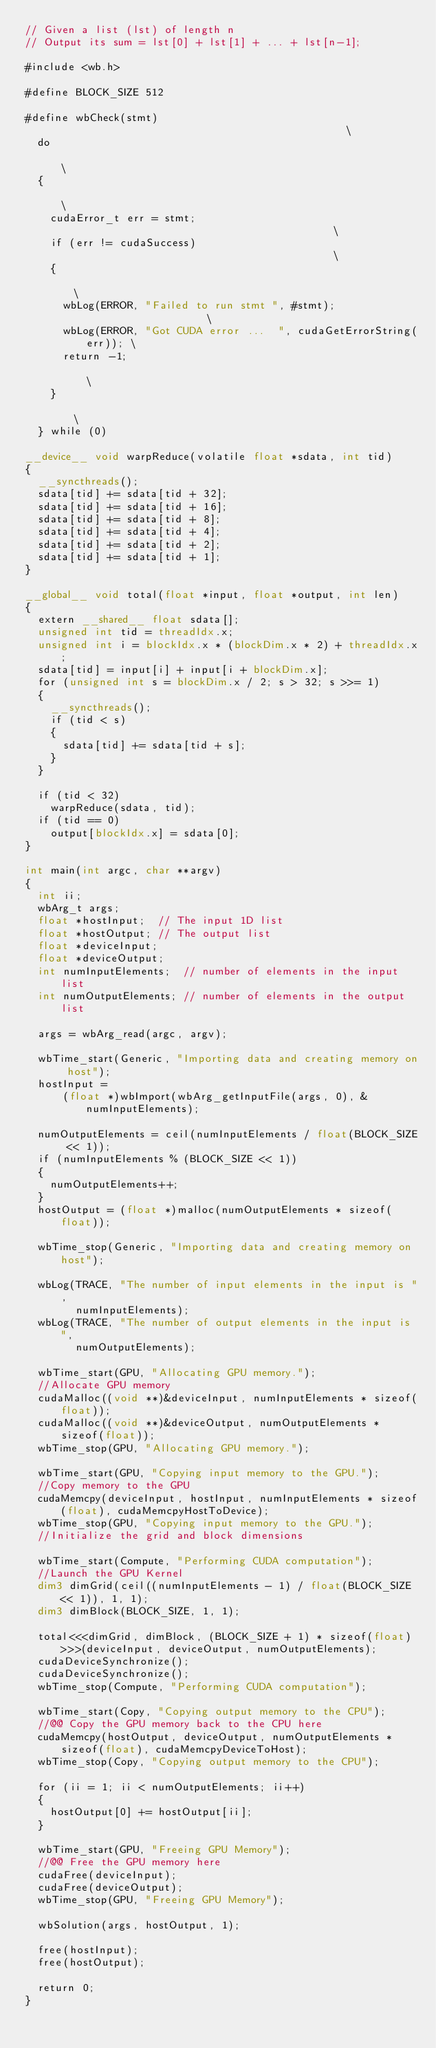Convert code to text. <code><loc_0><loc_0><loc_500><loc_500><_Cuda_>// Given a list (lst) of length n
// Output its sum = lst[0] + lst[1] + ... + lst[n-1];

#include <wb.h>

#define BLOCK_SIZE 512

#define wbCheck(stmt)                                                \
  do                                                                 \
  {                                                                  \
    cudaError_t err = stmt;                                          \
    if (err != cudaSuccess)                                          \
    {                                                                \
      wbLog(ERROR, "Failed to run stmt ", #stmt);                    \
      wbLog(ERROR, "Got CUDA error ...  ", cudaGetErrorString(err)); \
      return -1;                                                     \
    }                                                                \
  } while (0)

__device__ void warpReduce(volatile float *sdata, int tid)
{
  __syncthreads();
  sdata[tid] += sdata[tid + 32];
  sdata[tid] += sdata[tid + 16];
  sdata[tid] += sdata[tid + 8];
  sdata[tid] += sdata[tid + 4];
  sdata[tid] += sdata[tid + 2];
  sdata[tid] += sdata[tid + 1];
}

__global__ void total(float *input, float *output, int len)
{
  extern __shared__ float sdata[];
  unsigned int tid = threadIdx.x;
  unsigned int i = blockIdx.x * (blockDim.x * 2) + threadIdx.x;
  sdata[tid] = input[i] + input[i + blockDim.x];
  for (unsigned int s = blockDim.x / 2; s > 32; s >>= 1)
  {
    __syncthreads();
    if (tid < s)
    {
      sdata[tid] += sdata[tid + s];
    }
  }

  if (tid < 32)
    warpReduce(sdata, tid);
  if (tid == 0)
    output[blockIdx.x] = sdata[0];
}

int main(int argc, char **argv)
{
  int ii;
  wbArg_t args;
  float *hostInput;  // The input 1D list
  float *hostOutput; // The output list
  float *deviceInput;
  float *deviceOutput;
  int numInputElements;  // number of elements in the input list
  int numOutputElements; // number of elements in the output list

  args = wbArg_read(argc, argv);

  wbTime_start(Generic, "Importing data and creating memory on host");
  hostInput =
      (float *)wbImport(wbArg_getInputFile(args, 0), &numInputElements);

  numOutputElements = ceil(numInputElements / float(BLOCK_SIZE << 1));
  if (numInputElements % (BLOCK_SIZE << 1))
  {
    numOutputElements++;
  }
  hostOutput = (float *)malloc(numOutputElements * sizeof(float));

  wbTime_stop(Generic, "Importing data and creating memory on host");

  wbLog(TRACE, "The number of input elements in the input is ",
        numInputElements);
  wbLog(TRACE, "The number of output elements in the input is ",
        numOutputElements);

  wbTime_start(GPU, "Allocating GPU memory.");
  //Allocate GPU memory
  cudaMalloc((void **)&deviceInput, numInputElements * sizeof(float));
  cudaMalloc((void **)&deviceOutput, numOutputElements * sizeof(float));
  wbTime_stop(GPU, "Allocating GPU memory.");

  wbTime_start(GPU, "Copying input memory to the GPU.");
  //Copy memory to the GPU
  cudaMemcpy(deviceInput, hostInput, numInputElements * sizeof(float), cudaMemcpyHostToDevice);
  wbTime_stop(GPU, "Copying input memory to the GPU.");
  //Initialize the grid and block dimensions

  wbTime_start(Compute, "Performing CUDA computation");
  //Launch the GPU Kernel
  dim3 dimGrid(ceil((numInputElements - 1) / float(BLOCK_SIZE << 1)), 1, 1);
  dim3 dimBlock(BLOCK_SIZE, 1, 1);

  total<<<dimGrid, dimBlock, (BLOCK_SIZE + 1) * sizeof(float)>>>(deviceInput, deviceOutput, numOutputElements);
  cudaDeviceSynchronize();
  cudaDeviceSynchronize();
  wbTime_stop(Compute, "Performing CUDA computation");

  wbTime_start(Copy, "Copying output memory to the CPU");
  //@@ Copy the GPU memory back to the CPU here
  cudaMemcpy(hostOutput, deviceOutput, numOutputElements * sizeof(float), cudaMemcpyDeviceToHost);
  wbTime_stop(Copy, "Copying output memory to the CPU");

  for (ii = 1; ii < numOutputElements; ii++)
  {
    hostOutput[0] += hostOutput[ii];
  }

  wbTime_start(GPU, "Freeing GPU Memory");
  //@@ Free the GPU memory here
  cudaFree(deviceInput);
  cudaFree(deviceOutput);
  wbTime_stop(GPU, "Freeing GPU Memory");

  wbSolution(args, hostOutput, 1);

  free(hostInput);
  free(hostOutput);

  return 0;
}
</code> 